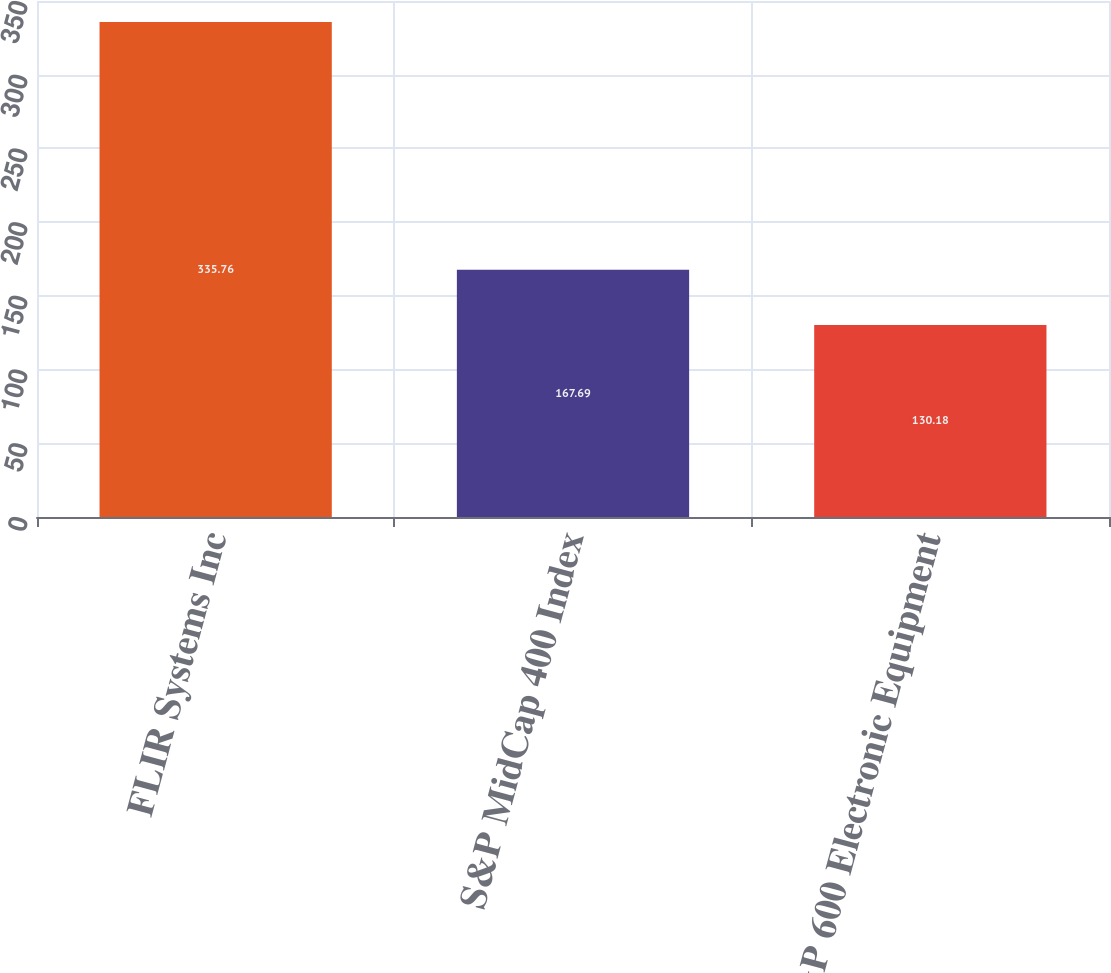Convert chart to OTSL. <chart><loc_0><loc_0><loc_500><loc_500><bar_chart><fcel>FLIR Systems Inc<fcel>S&P MidCap 400 Index<fcel>S&P 600 Electronic Equipment<nl><fcel>335.76<fcel>167.69<fcel>130.18<nl></chart> 